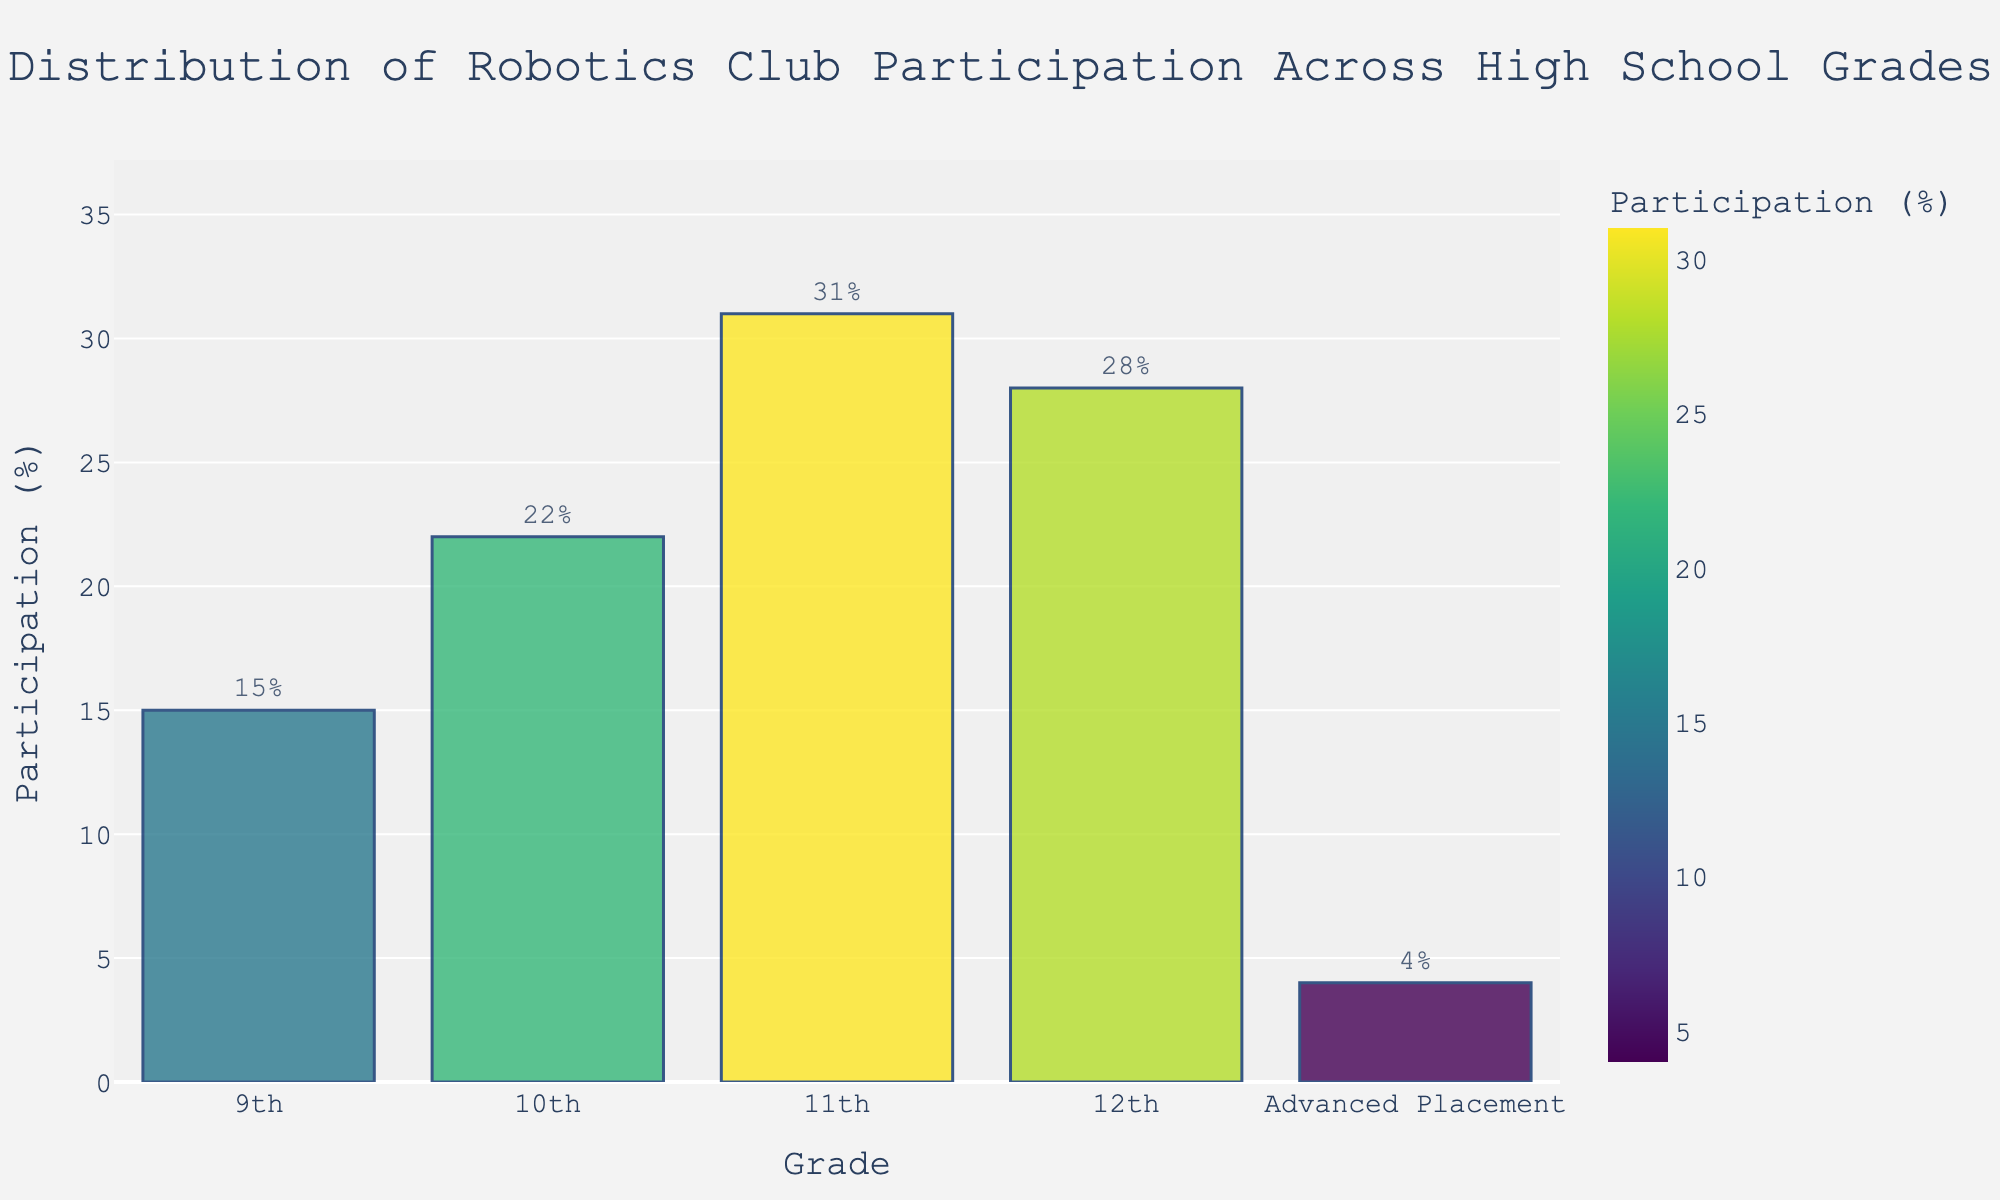What's the grade level with the highest participation percentage in the Robotics Club? Looking at the heights of the bars, the 11th grade has the tallest bar, indicating the highest participation percentage at 31%.
Answer: 11th grade What's the total participation percentage for 9th and 12th grades combined? The participation percentage for 9th grade is 15% and for 12th grade is 28%. Adding these together gives 15 + 28 = 43%.
Answer: 43% Which grade level has a smaller participation percentage, 10th grade or 12th grade? Comparing the heights of the 10th and 12th grade bars, 10th grade has a participation percentage of 22%, while 12th grade has 28%. Therefore, 10th grade has a smaller participation percentage.
Answer: 10th grade Is the participation percentage of Advanced Placement grade higher or lower than that of 9th grade? The bar for Advanced Placement shows 4% and the bar for 9th grade shows 15%. Therefore, the participation percentage for Advanced Placement is lower than that of 9th grade.
Answer: Lower What is the sum of the participation percentages of all grade levels? Adding up all the participation percentages: 15 (9th) + 22 (10th) + 31 (11th) + 28 (12th) + 4 (Advanced Placement) = 100%.
Answer: 100% How much greater is the participation percentage in 11th grade compared to 9th grade? The participation percentage for 11th grade is 31% and for 9th grade is 15%. Subtracting these gives 31 - 15 = 16%.
Answer: 16% Rank the grade levels from highest to lowest participation percentage. By viewing the bar heights:
1. 11th grade (31%)
2. 12th grade (28%)
3. 10th grade (22%)
4. 9th grade (15%)
5. Advanced Placement (4%)
Answer: 11th, 12th, 10th, 9th, Advanced Placement What percentage difference is there between the highest and lowest participation percentages? The highest participation percentage is 31% (11th grade) and the lowest is 4% (Advanced Placement). The difference is 31 - 4 = 27%.
Answer: 27% Which grades have higher participation percentages than 20%? The grades with bars greater than 20% are 10th (22%), 11th (31%), and 12th (28%).
Answer: 10th, 11th, 12th 